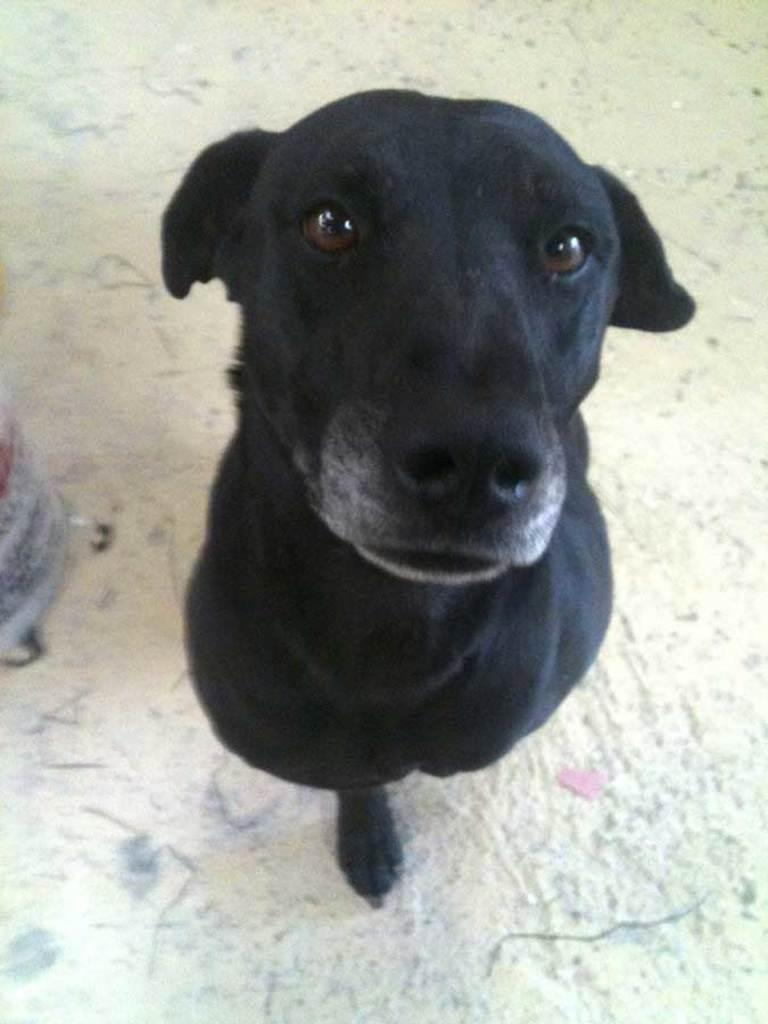What type of animal is in the image? There is a black color dog in the image. What is the dog doing in the image? The dog appears to be standing on the ground. What can be seen in the background of the image? There are objects placed on the ground in the background of the image. Where is the hospital located in the image? There is no hospital present in the image. What type of fan is visible in the image? There is no fan present in the image. 